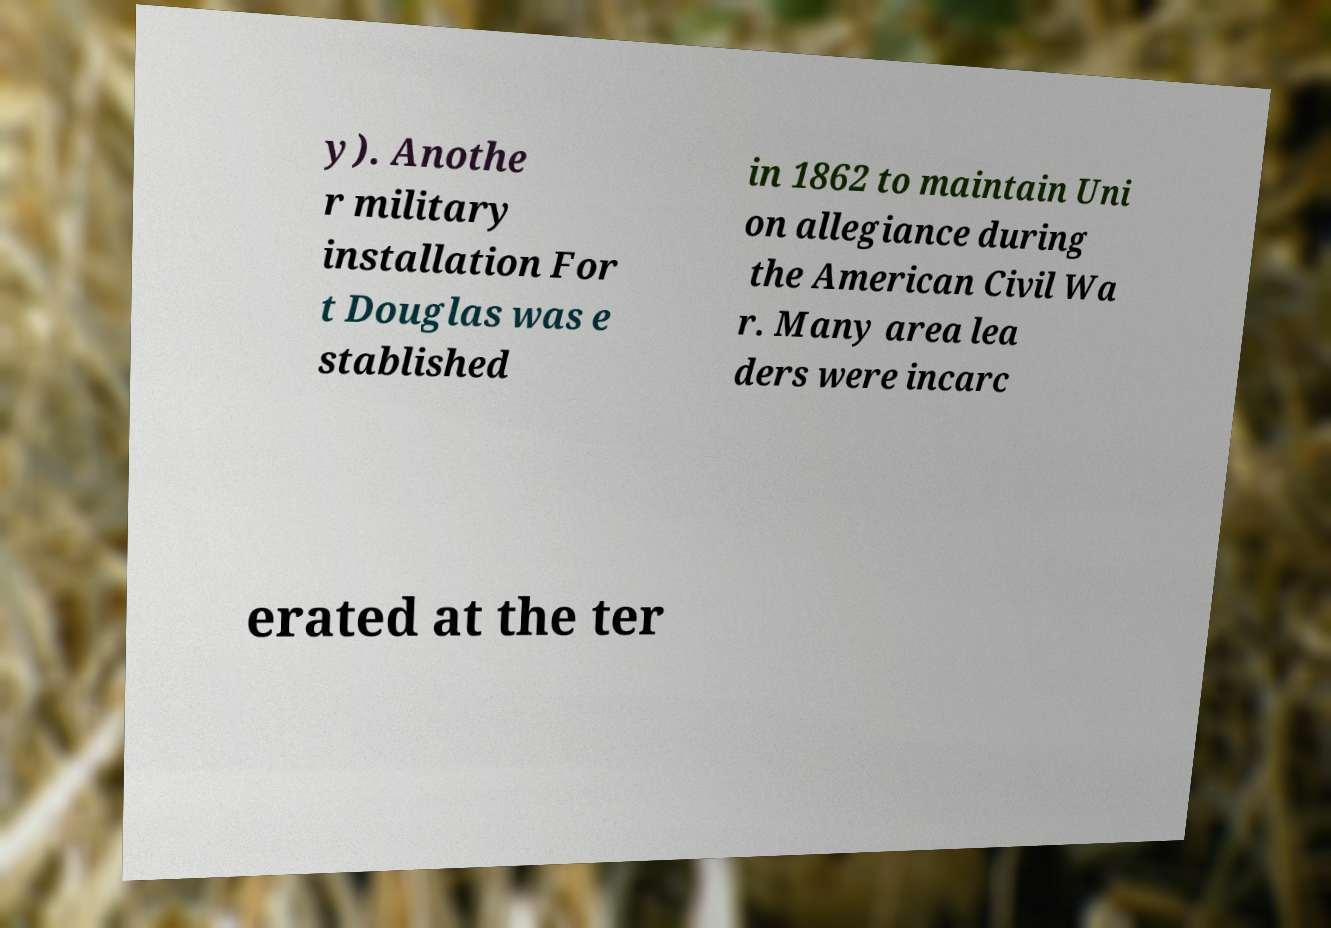Could you assist in decoding the text presented in this image and type it out clearly? y). Anothe r military installation For t Douglas was e stablished in 1862 to maintain Uni on allegiance during the American Civil Wa r. Many area lea ders were incarc erated at the ter 